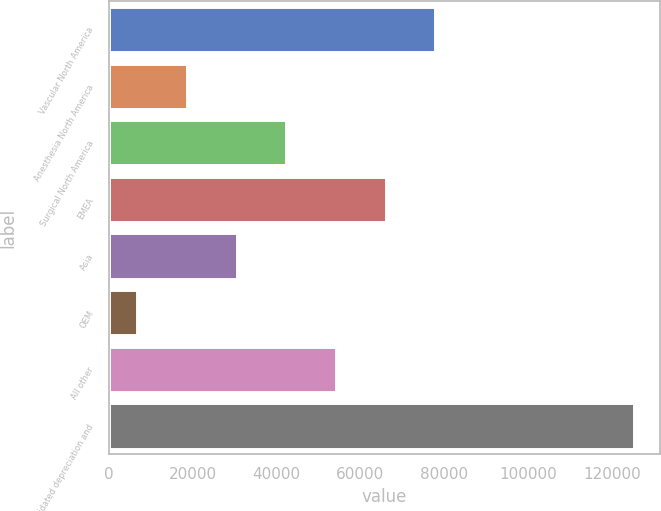<chart> <loc_0><loc_0><loc_500><loc_500><bar_chart><fcel>Vascular North America<fcel>Anesthesia North America<fcel>Surgical North America<fcel>EMEA<fcel>Asia<fcel>OEM<fcel>All other<fcel>Consolidated depreciation and<nl><fcel>77934<fcel>18684<fcel>42384<fcel>66084<fcel>30534<fcel>6834<fcel>54234<fcel>125334<nl></chart> 